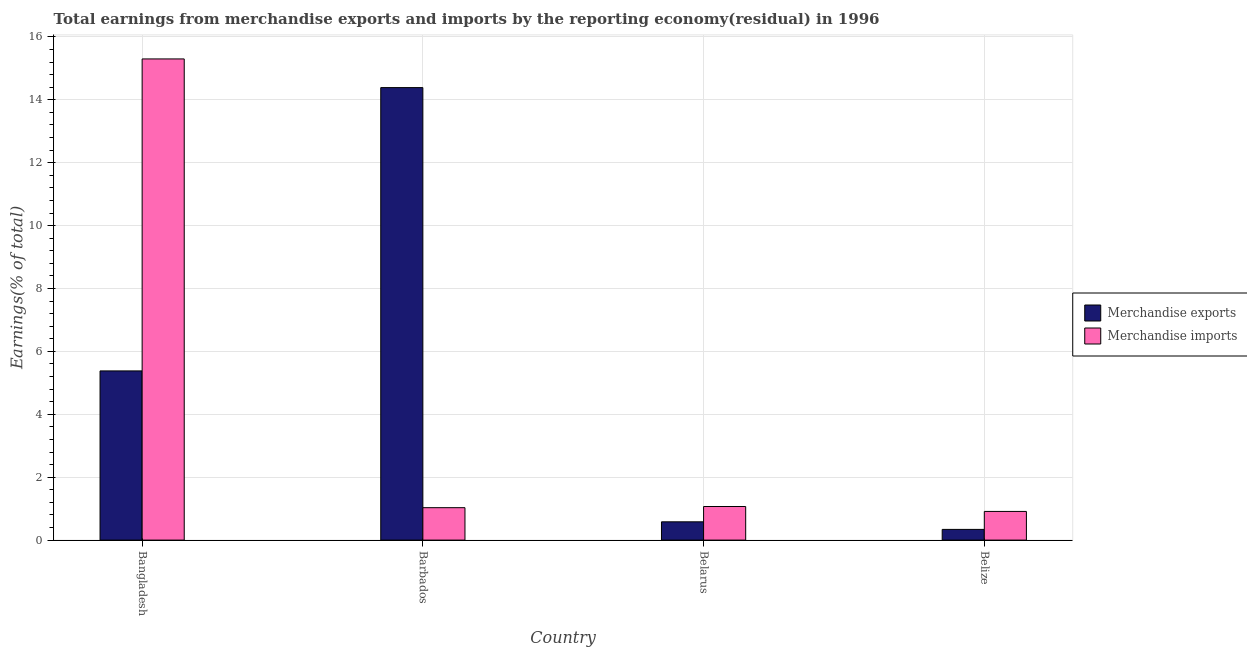How many different coloured bars are there?
Offer a terse response. 2. How many groups of bars are there?
Your answer should be compact. 4. Are the number of bars per tick equal to the number of legend labels?
Ensure brevity in your answer.  Yes. How many bars are there on the 3rd tick from the right?
Provide a short and direct response. 2. In how many cases, is the number of bars for a given country not equal to the number of legend labels?
Ensure brevity in your answer.  0. What is the earnings from merchandise imports in Barbados?
Your response must be concise. 1.03. Across all countries, what is the maximum earnings from merchandise exports?
Offer a very short reply. 14.39. Across all countries, what is the minimum earnings from merchandise exports?
Your response must be concise. 0.34. In which country was the earnings from merchandise imports minimum?
Your response must be concise. Belize. What is the total earnings from merchandise imports in the graph?
Offer a very short reply. 18.31. What is the difference between the earnings from merchandise exports in Barbados and that in Belarus?
Provide a succinct answer. 13.81. What is the difference between the earnings from merchandise imports in Bangladesh and the earnings from merchandise exports in Barbados?
Make the answer very short. 0.91. What is the average earnings from merchandise imports per country?
Ensure brevity in your answer.  4.58. What is the difference between the earnings from merchandise exports and earnings from merchandise imports in Barbados?
Offer a terse response. 13.36. In how many countries, is the earnings from merchandise imports greater than 0.8 %?
Offer a very short reply. 4. What is the ratio of the earnings from merchandise exports in Barbados to that in Belarus?
Offer a very short reply. 24.74. Is the difference between the earnings from merchandise exports in Bangladesh and Belize greater than the difference between the earnings from merchandise imports in Bangladesh and Belize?
Offer a very short reply. No. What is the difference between the highest and the second highest earnings from merchandise imports?
Offer a terse response. 14.23. What is the difference between the highest and the lowest earnings from merchandise imports?
Your response must be concise. 14.39. In how many countries, is the earnings from merchandise imports greater than the average earnings from merchandise imports taken over all countries?
Provide a short and direct response. 1. Is the sum of the earnings from merchandise imports in Bangladesh and Belize greater than the maximum earnings from merchandise exports across all countries?
Your answer should be very brief. Yes. What does the 2nd bar from the right in Bangladesh represents?
Make the answer very short. Merchandise exports. How many bars are there?
Offer a very short reply. 8. Are all the bars in the graph horizontal?
Keep it short and to the point. No. How many legend labels are there?
Provide a succinct answer. 2. How are the legend labels stacked?
Your answer should be very brief. Vertical. What is the title of the graph?
Give a very brief answer. Total earnings from merchandise exports and imports by the reporting economy(residual) in 1996. What is the label or title of the X-axis?
Make the answer very short. Country. What is the label or title of the Y-axis?
Offer a terse response. Earnings(% of total). What is the Earnings(% of total) in Merchandise exports in Bangladesh?
Provide a short and direct response. 5.38. What is the Earnings(% of total) in Merchandise imports in Bangladesh?
Your answer should be very brief. 15.3. What is the Earnings(% of total) in Merchandise exports in Barbados?
Keep it short and to the point. 14.39. What is the Earnings(% of total) of Merchandise imports in Barbados?
Your answer should be very brief. 1.03. What is the Earnings(% of total) of Merchandise exports in Belarus?
Your answer should be compact. 0.58. What is the Earnings(% of total) of Merchandise imports in Belarus?
Make the answer very short. 1.07. What is the Earnings(% of total) in Merchandise exports in Belize?
Provide a succinct answer. 0.34. What is the Earnings(% of total) in Merchandise imports in Belize?
Your answer should be very brief. 0.91. Across all countries, what is the maximum Earnings(% of total) of Merchandise exports?
Your answer should be very brief. 14.39. Across all countries, what is the maximum Earnings(% of total) of Merchandise imports?
Ensure brevity in your answer.  15.3. Across all countries, what is the minimum Earnings(% of total) of Merchandise exports?
Provide a succinct answer. 0.34. Across all countries, what is the minimum Earnings(% of total) of Merchandise imports?
Ensure brevity in your answer.  0.91. What is the total Earnings(% of total) of Merchandise exports in the graph?
Ensure brevity in your answer.  20.69. What is the total Earnings(% of total) of Merchandise imports in the graph?
Provide a succinct answer. 18.31. What is the difference between the Earnings(% of total) of Merchandise exports in Bangladesh and that in Barbados?
Provide a succinct answer. -9.01. What is the difference between the Earnings(% of total) of Merchandise imports in Bangladesh and that in Barbados?
Provide a succinct answer. 14.27. What is the difference between the Earnings(% of total) of Merchandise exports in Bangladesh and that in Belarus?
Give a very brief answer. 4.8. What is the difference between the Earnings(% of total) of Merchandise imports in Bangladesh and that in Belarus?
Provide a succinct answer. 14.23. What is the difference between the Earnings(% of total) in Merchandise exports in Bangladesh and that in Belize?
Your answer should be very brief. 5.04. What is the difference between the Earnings(% of total) of Merchandise imports in Bangladesh and that in Belize?
Provide a short and direct response. 14.39. What is the difference between the Earnings(% of total) in Merchandise exports in Barbados and that in Belarus?
Make the answer very short. 13.81. What is the difference between the Earnings(% of total) in Merchandise imports in Barbados and that in Belarus?
Provide a short and direct response. -0.04. What is the difference between the Earnings(% of total) in Merchandise exports in Barbados and that in Belize?
Provide a short and direct response. 14.05. What is the difference between the Earnings(% of total) of Merchandise imports in Barbados and that in Belize?
Your answer should be compact. 0.12. What is the difference between the Earnings(% of total) of Merchandise exports in Belarus and that in Belize?
Your answer should be very brief. 0.24. What is the difference between the Earnings(% of total) in Merchandise imports in Belarus and that in Belize?
Offer a very short reply. 0.16. What is the difference between the Earnings(% of total) in Merchandise exports in Bangladesh and the Earnings(% of total) in Merchandise imports in Barbados?
Offer a very short reply. 4.35. What is the difference between the Earnings(% of total) of Merchandise exports in Bangladesh and the Earnings(% of total) of Merchandise imports in Belarus?
Your response must be concise. 4.31. What is the difference between the Earnings(% of total) of Merchandise exports in Bangladesh and the Earnings(% of total) of Merchandise imports in Belize?
Your response must be concise. 4.47. What is the difference between the Earnings(% of total) in Merchandise exports in Barbados and the Earnings(% of total) in Merchandise imports in Belarus?
Offer a very short reply. 13.32. What is the difference between the Earnings(% of total) of Merchandise exports in Barbados and the Earnings(% of total) of Merchandise imports in Belize?
Ensure brevity in your answer.  13.48. What is the difference between the Earnings(% of total) in Merchandise exports in Belarus and the Earnings(% of total) in Merchandise imports in Belize?
Make the answer very short. -0.33. What is the average Earnings(% of total) of Merchandise exports per country?
Your answer should be very brief. 5.17. What is the average Earnings(% of total) of Merchandise imports per country?
Give a very brief answer. 4.58. What is the difference between the Earnings(% of total) of Merchandise exports and Earnings(% of total) of Merchandise imports in Bangladesh?
Provide a succinct answer. -9.92. What is the difference between the Earnings(% of total) of Merchandise exports and Earnings(% of total) of Merchandise imports in Barbados?
Keep it short and to the point. 13.36. What is the difference between the Earnings(% of total) in Merchandise exports and Earnings(% of total) in Merchandise imports in Belarus?
Make the answer very short. -0.49. What is the difference between the Earnings(% of total) in Merchandise exports and Earnings(% of total) in Merchandise imports in Belize?
Your answer should be compact. -0.57. What is the ratio of the Earnings(% of total) in Merchandise exports in Bangladesh to that in Barbados?
Provide a succinct answer. 0.37. What is the ratio of the Earnings(% of total) of Merchandise imports in Bangladesh to that in Barbados?
Your response must be concise. 14.84. What is the ratio of the Earnings(% of total) in Merchandise exports in Bangladesh to that in Belarus?
Your answer should be compact. 9.25. What is the ratio of the Earnings(% of total) in Merchandise imports in Bangladesh to that in Belarus?
Your response must be concise. 14.32. What is the ratio of the Earnings(% of total) of Merchandise exports in Bangladesh to that in Belize?
Provide a succinct answer. 15.8. What is the ratio of the Earnings(% of total) of Merchandise imports in Bangladesh to that in Belize?
Provide a short and direct response. 16.78. What is the ratio of the Earnings(% of total) in Merchandise exports in Barbados to that in Belarus?
Offer a terse response. 24.74. What is the ratio of the Earnings(% of total) in Merchandise exports in Barbados to that in Belize?
Your response must be concise. 42.25. What is the ratio of the Earnings(% of total) in Merchandise imports in Barbados to that in Belize?
Provide a short and direct response. 1.13. What is the ratio of the Earnings(% of total) in Merchandise exports in Belarus to that in Belize?
Offer a terse response. 1.71. What is the ratio of the Earnings(% of total) in Merchandise imports in Belarus to that in Belize?
Keep it short and to the point. 1.17. What is the difference between the highest and the second highest Earnings(% of total) in Merchandise exports?
Your response must be concise. 9.01. What is the difference between the highest and the second highest Earnings(% of total) in Merchandise imports?
Keep it short and to the point. 14.23. What is the difference between the highest and the lowest Earnings(% of total) of Merchandise exports?
Ensure brevity in your answer.  14.05. What is the difference between the highest and the lowest Earnings(% of total) in Merchandise imports?
Provide a short and direct response. 14.39. 